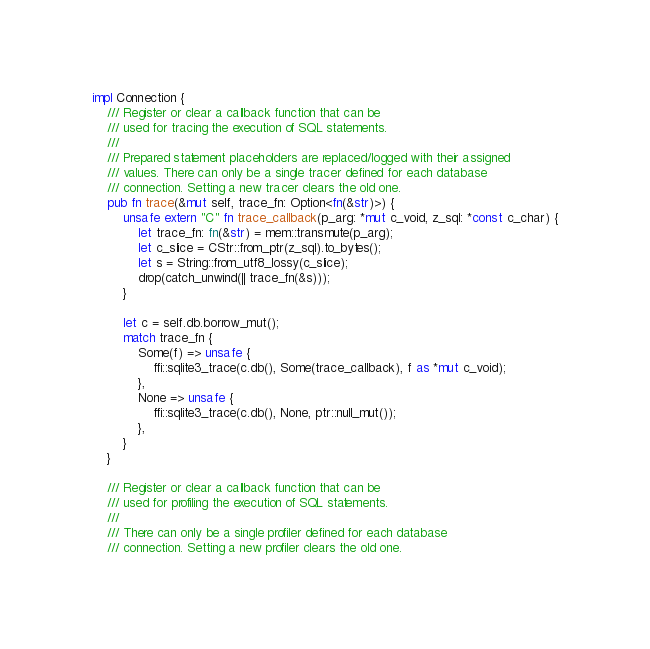Convert code to text. <code><loc_0><loc_0><loc_500><loc_500><_Rust_>impl Connection {
    /// Register or clear a callback function that can be
    /// used for tracing the execution of SQL statements.
    ///
    /// Prepared statement placeholders are replaced/logged with their assigned
    /// values. There can only be a single tracer defined for each database
    /// connection. Setting a new tracer clears the old one.
    pub fn trace(&mut self, trace_fn: Option<fn(&str)>) {
        unsafe extern "C" fn trace_callback(p_arg: *mut c_void, z_sql: *const c_char) {
            let trace_fn: fn(&str) = mem::transmute(p_arg);
            let c_slice = CStr::from_ptr(z_sql).to_bytes();
            let s = String::from_utf8_lossy(c_slice);
            drop(catch_unwind(|| trace_fn(&s)));
        }

        let c = self.db.borrow_mut();
        match trace_fn {
            Some(f) => unsafe {
                ffi::sqlite3_trace(c.db(), Some(trace_callback), f as *mut c_void);
            },
            None => unsafe {
                ffi::sqlite3_trace(c.db(), None, ptr::null_mut());
            },
        }
    }

    /// Register or clear a callback function that can be
    /// used for profiling the execution of SQL statements.
    ///
    /// There can only be a single profiler defined for each database
    /// connection. Setting a new profiler clears the old one.</code> 